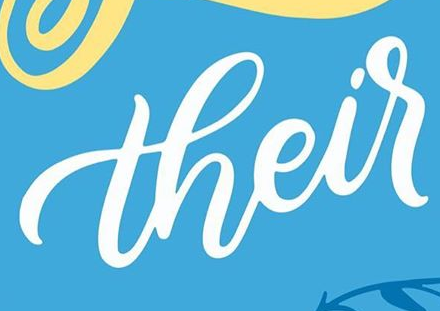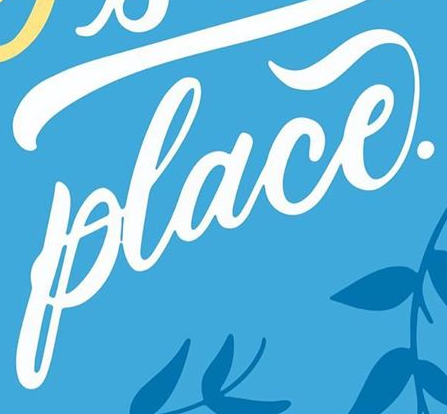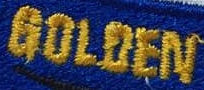Transcribe the words shown in these images in order, separated by a semicolon. their; place.; GOLOEN 